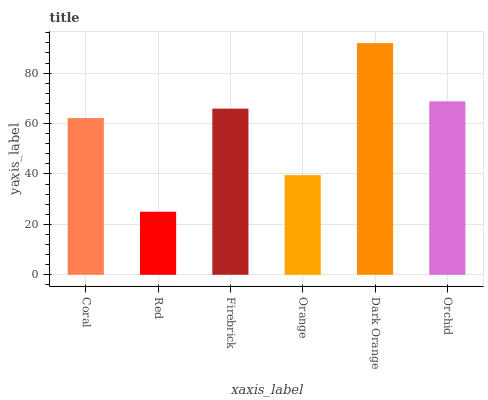Is Red the minimum?
Answer yes or no. Yes. Is Dark Orange the maximum?
Answer yes or no. Yes. Is Firebrick the minimum?
Answer yes or no. No. Is Firebrick the maximum?
Answer yes or no. No. Is Firebrick greater than Red?
Answer yes or no. Yes. Is Red less than Firebrick?
Answer yes or no. Yes. Is Red greater than Firebrick?
Answer yes or no. No. Is Firebrick less than Red?
Answer yes or no. No. Is Firebrick the high median?
Answer yes or no. Yes. Is Coral the low median?
Answer yes or no. Yes. Is Orchid the high median?
Answer yes or no. No. Is Dark Orange the low median?
Answer yes or no. No. 